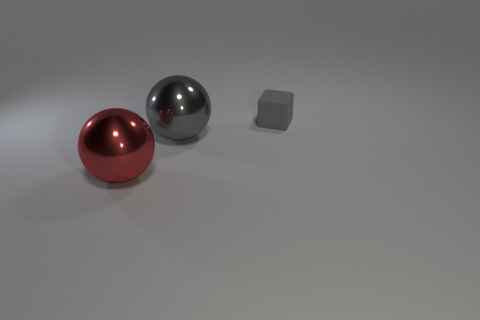Subtract all purple spheres. Subtract all green cylinders. How many spheres are left? 2 Add 2 large gray things. How many objects exist? 5 Subtract all balls. How many objects are left? 1 Add 3 tiny matte objects. How many tiny matte objects are left? 4 Add 1 gray balls. How many gray balls exist? 2 Subtract 1 gray cubes. How many objects are left? 2 Subtract all tiny yellow rubber balls. Subtract all balls. How many objects are left? 1 